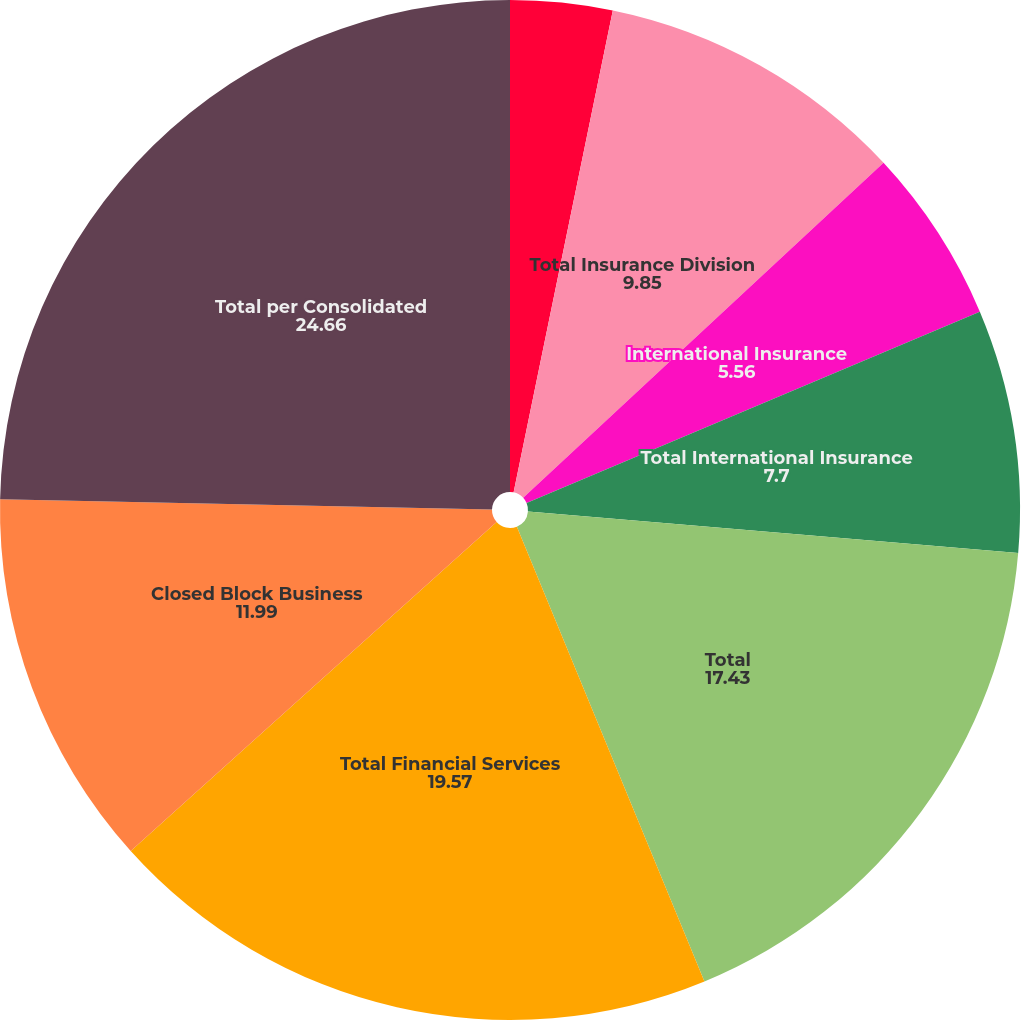Convert chart. <chart><loc_0><loc_0><loc_500><loc_500><pie_chart><fcel>Individual Life and Annuities<fcel>Total Insurance Division<fcel>International Insurance<fcel>Total International Insurance<fcel>Total<fcel>Total Financial Services<fcel>Closed Block Business<fcel>Total per Consolidated<nl><fcel>3.23%<fcel>9.85%<fcel>5.56%<fcel>7.7%<fcel>17.43%<fcel>19.57%<fcel>11.99%<fcel>24.66%<nl></chart> 